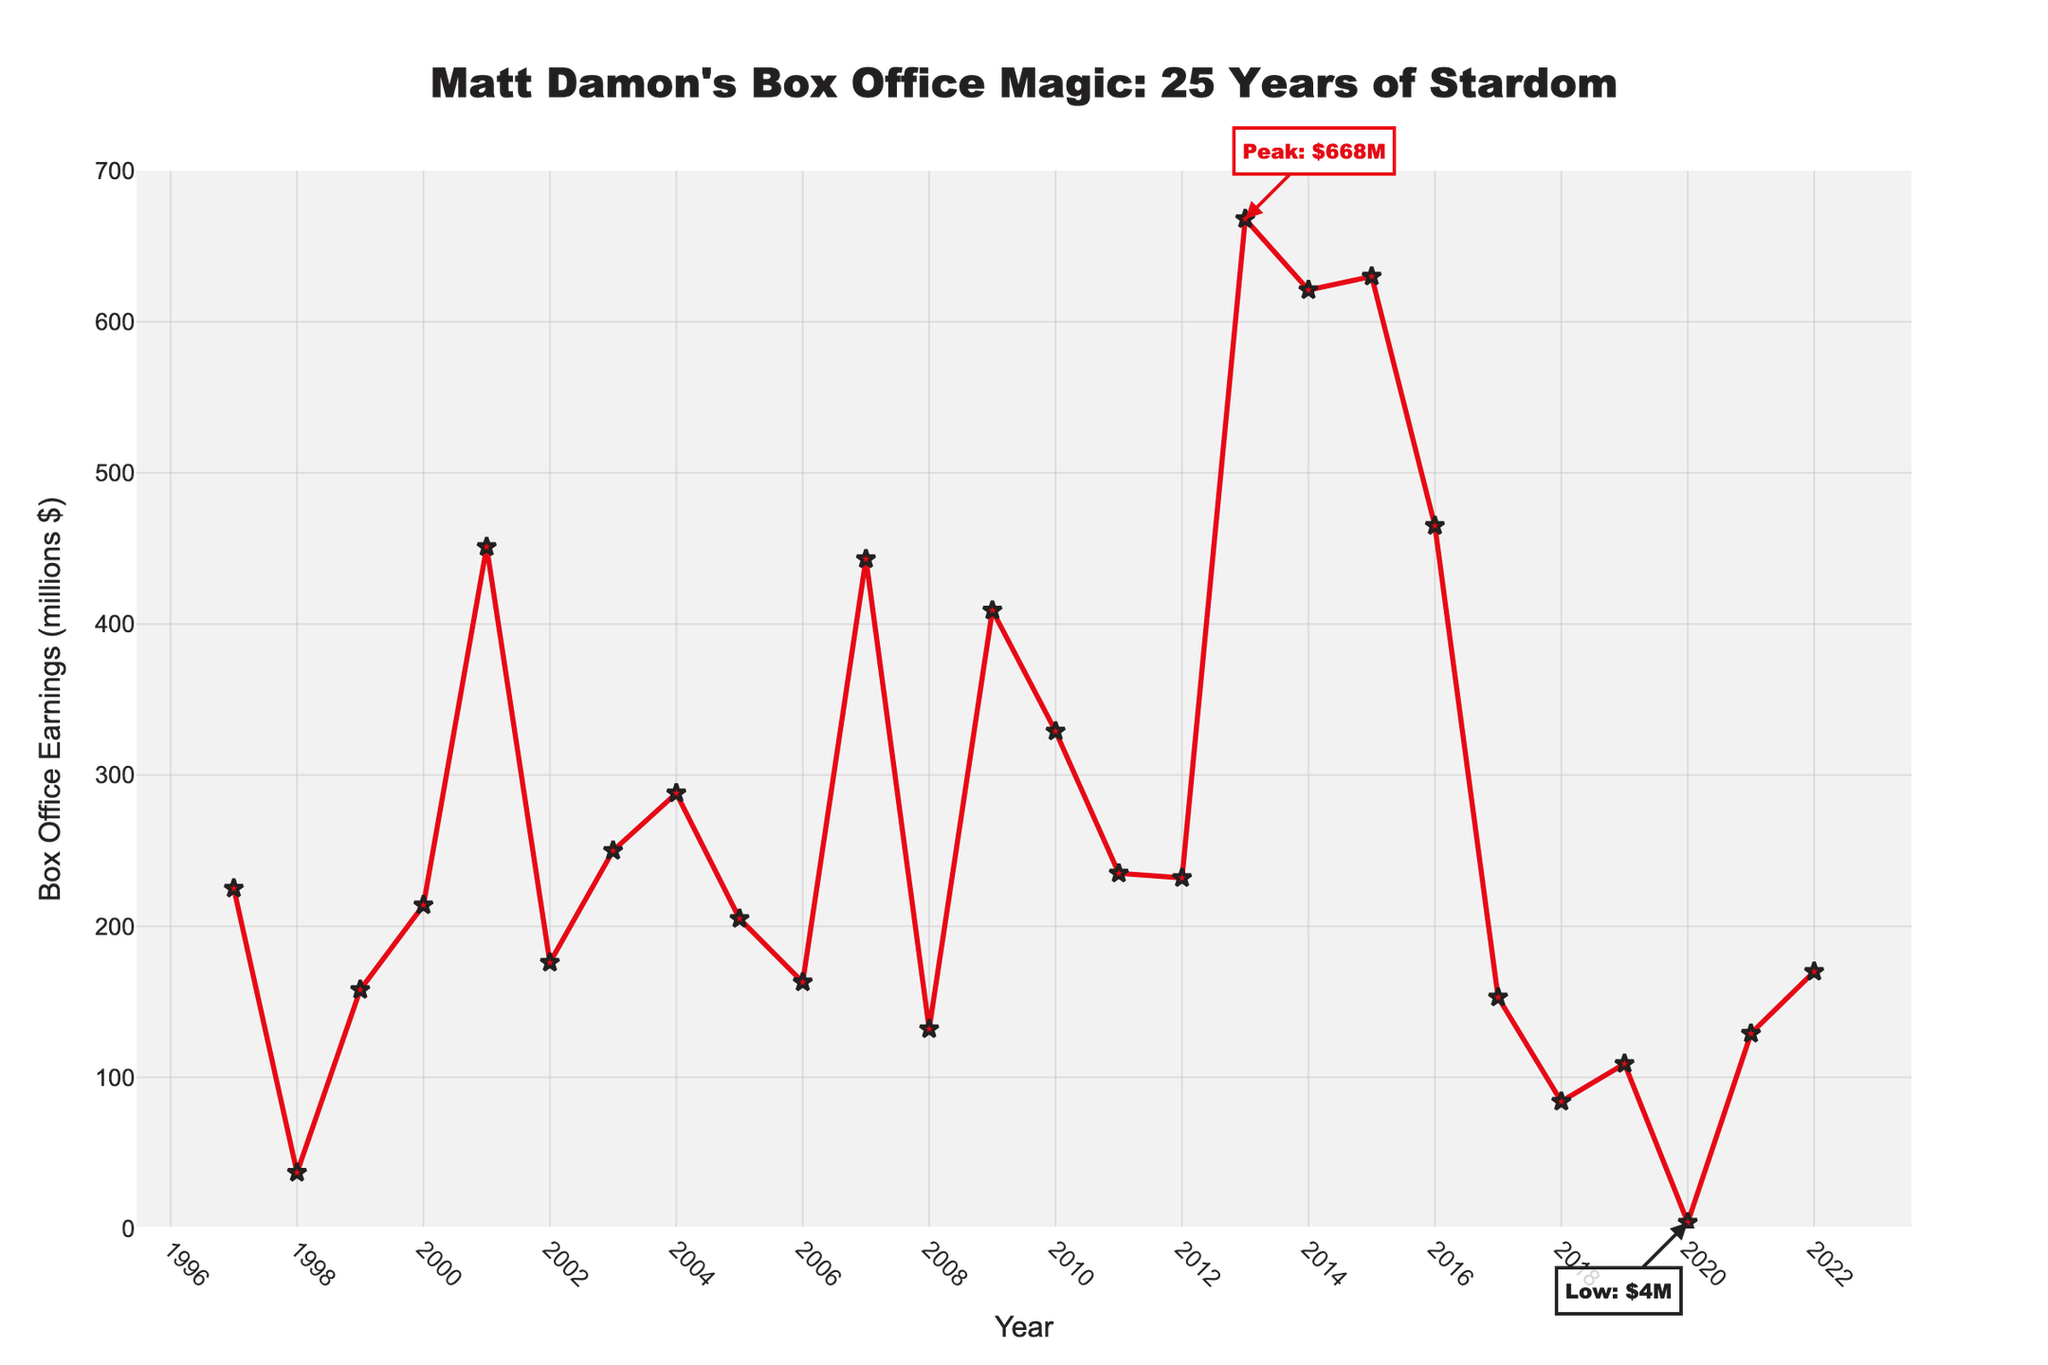What's the highest box office earnings in Matt Damon's career over the past 25 years? The highest box office earnings can be identified by looking at the peak of the line chart. The highest point is annotated as "Peak: $668M."
Answer: $668M What year did Matt Damon have the lowest box office earnings? The lowest box office earnings can be found at the lowest point of the chart. It is annotated as "Low: $4M" and corresponds to the year 2020.
Answer: 2020 How did the box office earnings in 2003 compare to those in 2001? Locate the points for 2003 and 2001 on the line chart. The earnings in 2003 are around $250 million, whereas the earnings in 2001 are about $451 million.
Answer: 2001 was higher Was there a steady increase or decrease in Matt Damon's box office earnings from 2010 to 2014? Observe the trend from 2010 to 2014: the earnings went from about $329M in 2010, to $235M in 2011, to $232M in 2012, then increased to $668M in 2013 and $621M in 2014. The trend is not steady; it fluctuates with a significant peak in 2013.
Answer: Fluctuated with a peak in 2013 What is the difference in box office earnings between the highest year and the lowest year? The highest earnings are $668M (2013) and the lowest are $4M (2020). The difference is calculated as $668M - $4M.
Answer: $664M Between which consecutive years did Matt Damon experience the largest increase in box office earnings? Identify the year-to-year differences by following the trend line. The largest increase in box office earnings happened between 2012 ($232M) and 2013 ($668M), an increase of $668M - $232M = $436M.
Answer: 2012 to 2013 Which year represents the median value of box office earnings over the 25-year period? To find the median, first arrange the earnings in ascending order and find the middle value. Since there are 25 years, the median is the 13th value in the ordered list. From the data, the median year corresponds to 2010 with earnings of $329 million.
Answer: 2010 Did Matt Damon's box office earnings show a downward trend after his peak in 2013? Examine the trend line after the peak in 2013 ($668M). The following years show earnings of $621M (2014), $630M (2015), $465M (2016), $153M (2017), $84M (2018), $109M (2019), $4M (2020), and $129M (2021). So, there is a general downward trend with some fluctuations.
Answer: Yes, with fluctuations What is the average box office earnings from 2018 to 2022? Sum the earnings from 2018 to 2022 and divide by the number of years. Earnings are $84M (2018), $109M (2019), $4M (2020), $129M (2021), and $170M (2022). The total is $496M and the average is $496M / 5.
Answer: $99.2M 